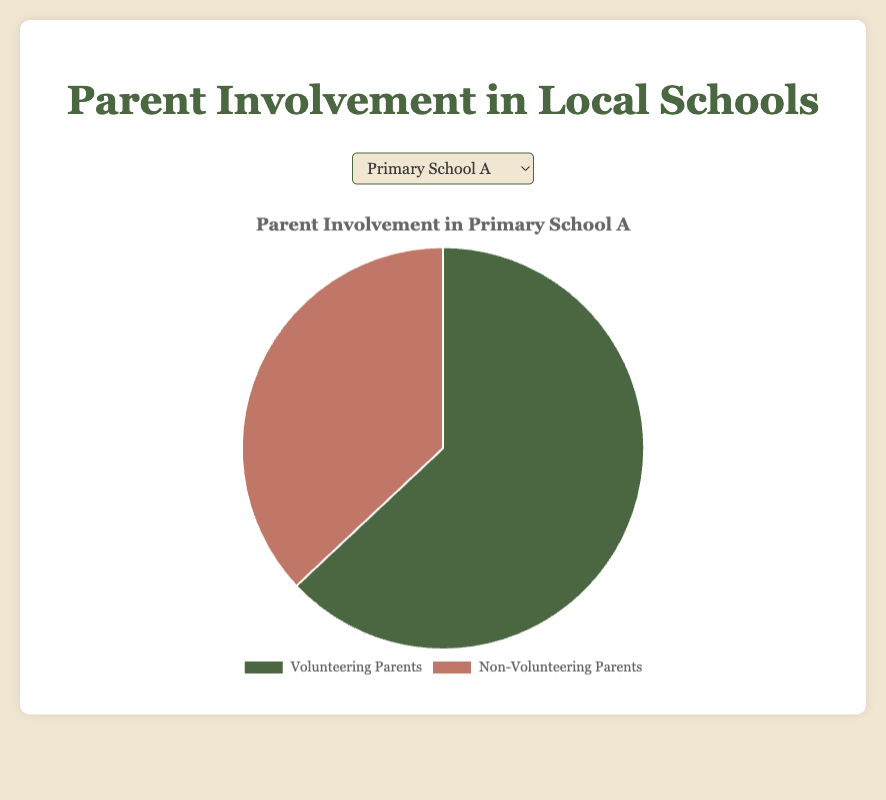What is the percentage of volunteering parents in Primary School A? Look at the data related to Primary School A in the pie chart. The percentage shown for volunteering parents is 63%.
Answer: 63% Which school has the highest percentage of non-volunteering parents? Compare the percentages of non-volunteering parents across all schools. Primary School B has the highest percentage at 45%.
Answer: Primary School B Is the percentage of volunteering parents higher in Primary School A or Secondary School B? Compare the percentage of volunteering parents between Primary School A and Secondary School B. Primary School A has 63% while Secondary School B has 60%.
Answer: Primary School A What's the difference in the percentage of non-volunteering parents between Secondary School A and Secondary School B? Subtract the percentage of non-volunteering parents in Secondary School B from that in Secondary School A: 40% - 30%.
Answer: 10% What is the combined percentage of non-volunteering parents for both primary schools? Sum the percentage of non-volunteering parents for Primary School A and Primary School B: 37% + 45%.
Answer: 82% How does the percentage of volunteering parents in Secondary School A compare to that in Primary School B? Compare the percentage of volunteering parents between Secondary School A and Primary School B. Secondary School A has 70% and Primary School B has 55%.
Answer: Secondary School A is higher What color represents non-volunteering parents in the pie charts? Observe the color coding in the pie chart legend for non-volunteering parents. The color used here is '#c17767'.
Answer: Red If Secondary School A's non-volunteering parents increased by 10%, what would their new percentage be? Add 10% to the existing percentage of non-volunteering parents in Secondary School A: 30% + 10%.
Answer: 40% Which school has the most balanced involvement, meaning the smallest difference between volunteering and non-volunteering parents? Determine the difference between the percentages of volunteering and non-volunteering parents for all schools. Primary School B has the smallest difference: 55% volunteering - 45% non-volunteering = 10%.
Answer: Primary School B 